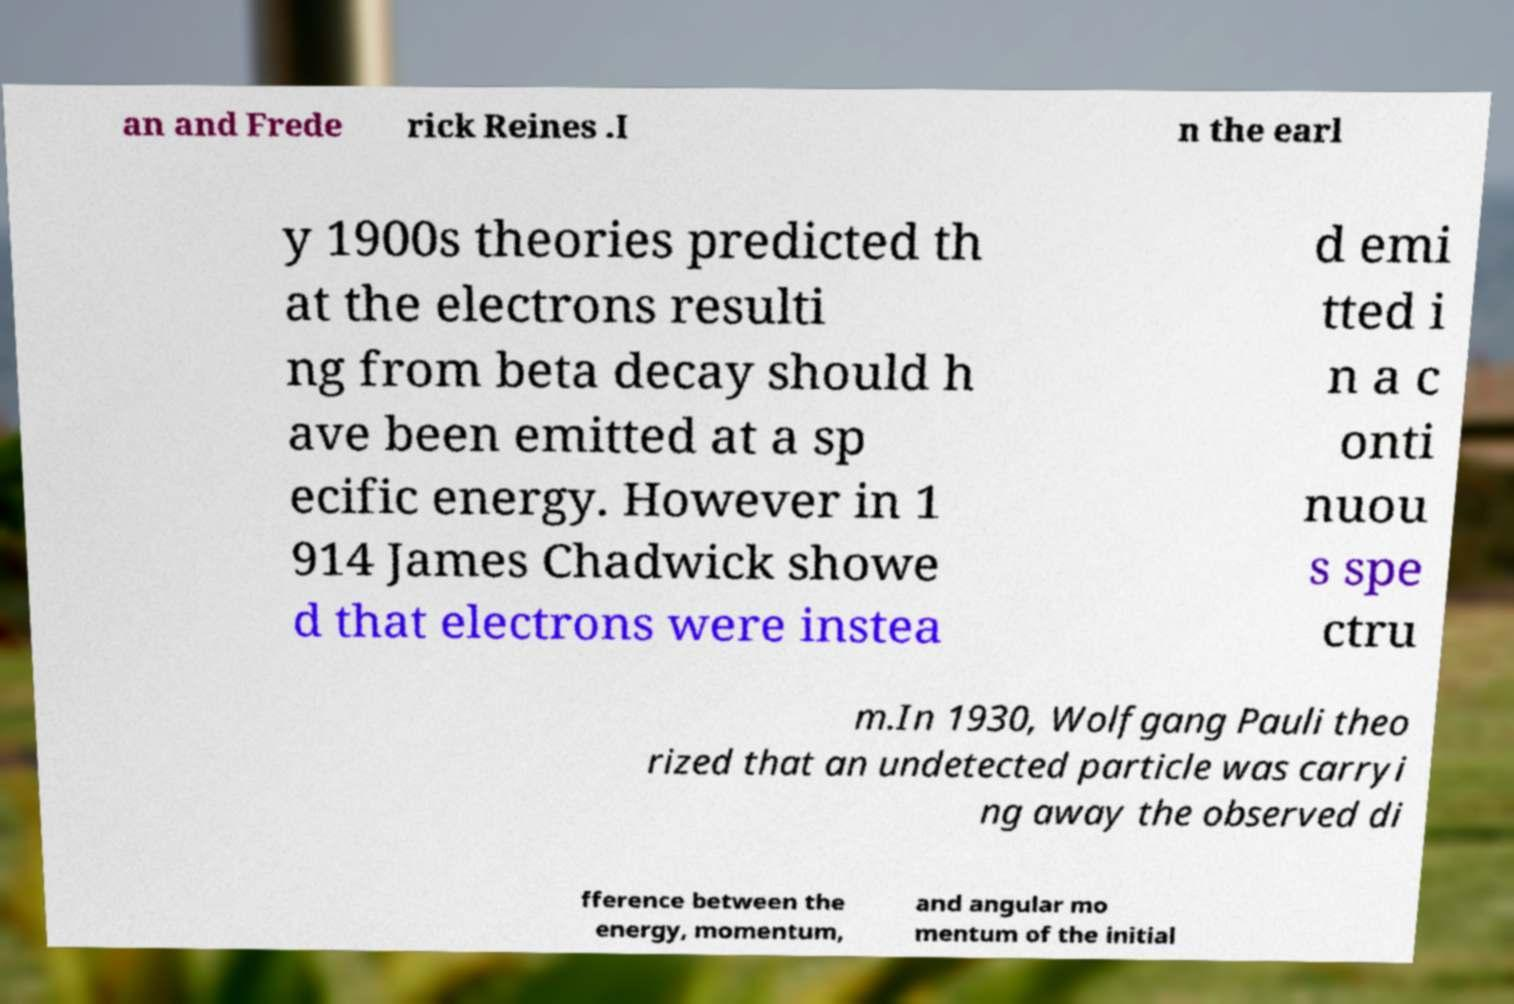I need the written content from this picture converted into text. Can you do that? an and Frede rick Reines .I n the earl y 1900s theories predicted th at the electrons resulti ng from beta decay should h ave been emitted at a sp ecific energy. However in 1 914 James Chadwick showe d that electrons were instea d emi tted i n a c onti nuou s spe ctru m.In 1930, Wolfgang Pauli theo rized that an undetected particle was carryi ng away the observed di fference between the energy, momentum, and angular mo mentum of the initial 